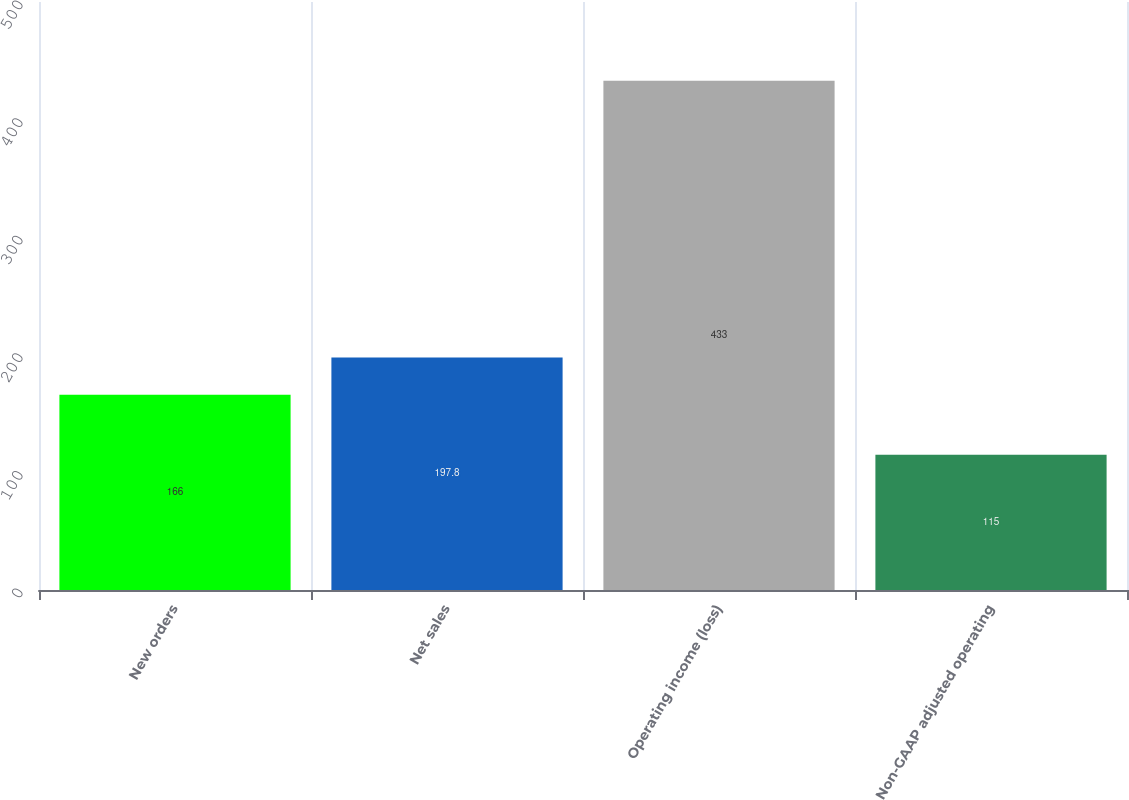Convert chart. <chart><loc_0><loc_0><loc_500><loc_500><bar_chart><fcel>New orders<fcel>Net sales<fcel>Operating income (loss)<fcel>Non-GAAP adjusted operating<nl><fcel>166<fcel>197.8<fcel>433<fcel>115<nl></chart> 